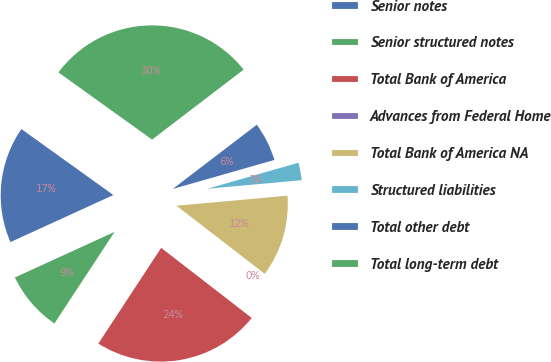<chart> <loc_0><loc_0><loc_500><loc_500><pie_chart><fcel>Senior notes<fcel>Senior structured notes<fcel>Total Bank of America<fcel>Advances from Federal Home<fcel>Total Bank of America NA<fcel>Structured liabilities<fcel>Total other debt<fcel>Total long-term debt<nl><fcel>16.73%<fcel>8.93%<fcel>23.76%<fcel>0.02%<fcel>11.9%<fcel>2.99%<fcel>5.96%<fcel>29.71%<nl></chart> 